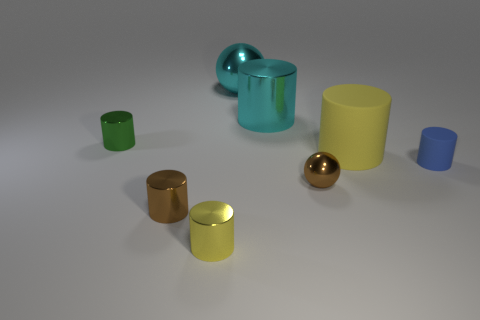There is a green shiny thing; does it have the same size as the metallic sphere in front of the green object?
Make the answer very short. Yes. There is a shiny object that is right of the tiny yellow cylinder and in front of the small green thing; what shape is it?
Keep it short and to the point. Sphere. There is a blue cylinder that is made of the same material as the large yellow cylinder; what size is it?
Your answer should be compact. Small. There is a yellow object behind the tiny blue thing; how many big cyan metallic cylinders are on the right side of it?
Provide a succinct answer. 0. Do the small brown thing on the right side of the small yellow metallic thing and the large yellow cylinder have the same material?
Provide a succinct answer. No. Is there anything else that has the same material as the tiny green thing?
Your response must be concise. Yes. There is a rubber object in front of the yellow thing that is behind the tiny blue rubber object; how big is it?
Offer a terse response. Small. How big is the yellow cylinder behind the yellow thing on the left side of the large cylinder to the left of the yellow matte cylinder?
Ensure brevity in your answer.  Large. There is a small brown shiny object in front of the brown sphere; is it the same shape as the big object that is in front of the tiny green shiny cylinder?
Provide a short and direct response. Yes. What number of other objects are the same color as the small ball?
Make the answer very short. 1. 